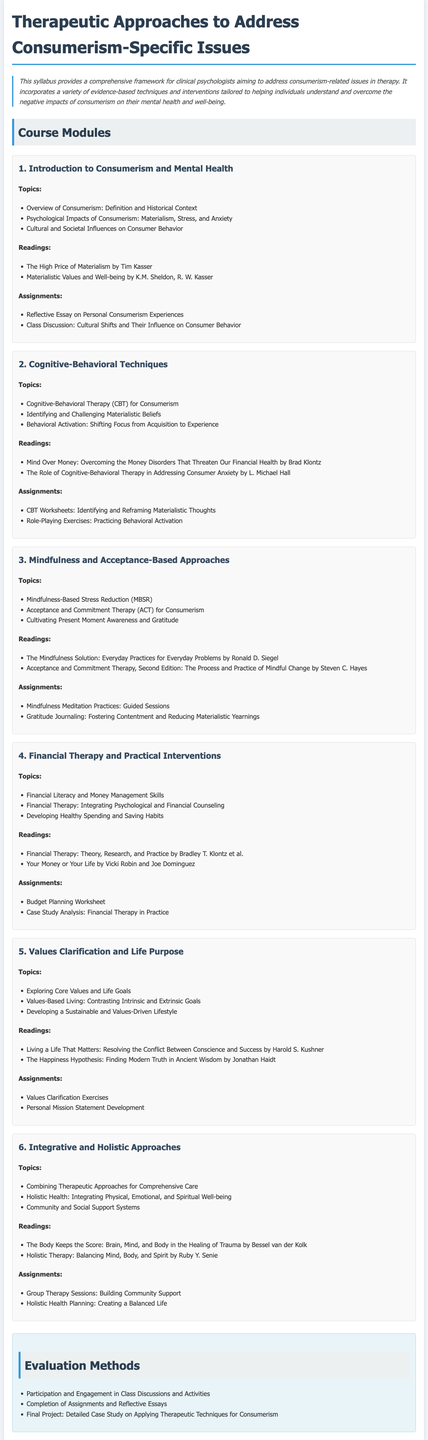what is the title of the syllabus? The title can be found at the top of the document, clearly stated.
Answer: Therapeutic Approaches to Address Consumerism-Specific Issues how many modules are included in the syllabus? By counting the modules listed in the document, we find the total.
Answer: 6 who is the author of "The High Price of Materialism"? The author of this reading is mentioned in the readings section of the first module.
Answer: Tim Kasser what is a key topic in the second module? The second module includes multiple topics, one of which is indicated.
Answer: Cognitive-Behavioral Therapy (CBT) for Consumerism which reading discusses financial therapy? The document includes readings that can be directly linked to financial therapy.
Answer: Financial Therapy: Theory, Research, and Practice mention one assignment for the third module. Each module lists assignments, one of which is clearly specified in the third module section.
Answer: Mindfulness Meditation Practices: Guided Sessions what is the purpose of values clarification exercises? This is inferred from the context of their placement within the fifth module.
Answer: To explore core values and life goals which approach combines therapeutic techniques for comprehensive care? One of the key topics in the sixth module addresses this specific approach.
Answer: Integrative and Holistic Approaches what type of final project is included in the evaluation methods? The evaluation methods section outlines this specific requirement.
Answer: Detailed Case Study on Applying Therapeutic Techniques for Consumerism 